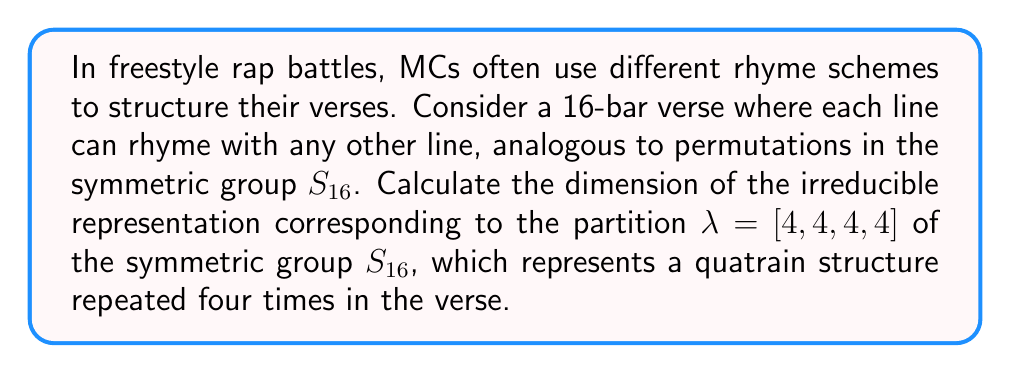Help me with this question. To calculate the dimension of the irreducible representation for the given partition, we'll use the hook length formula:

1) The hook length formula for the dimension of an irreducible representation of $S_n$ corresponding to a partition $\lambda$ is:

   $$\dim V_\lambda = \frac{n!}{\prod_{(i,j) \in \lambda} h(i,j)}$$

   where $h(i,j)$ is the hook length of the box $(i,j)$ in the Young diagram of $\lambda$.

2) For $\lambda = [4,4,4,4]$, the Young diagram is a $4 \times 4$ square.

3) Calculate the hook lengths for each box:
   $$\begin{array}{|c|c|c|c|}
   \hline
   7 & 6 & 5 & 4 \\
   \hline
   6 & 5 & 4 & 3 \\
   \hline
   5 & 4 & 3 & 2 \\
   \hline
   4 & 3 & 2 & 1 \\
   \hline
   \end{array}$$

4) Multiply all hook lengths:
   $$(7 \cdot 6 \cdot 5 \cdot 4) \cdot (6 \cdot 5 \cdot 4 \cdot 3) \cdot (5 \cdot 4 \cdot 3 \cdot 2) \cdot (4 \cdot 3 \cdot 2 \cdot 1)$$
   $$ = 7! \cdot 6! \cdot 5! \cdot 4!$$

5) Apply the formula:
   $$\dim V_{[4,4,4,4]} = \frac{16!}{7! \cdot 6! \cdot 5! \cdot 4!}$$

6) Simplify:
   $$\dim V_{[4,4,4,4]} = \frac{16 \cdot 15 \cdot 14 \cdot 13 \cdot 12 \cdot 11 \cdot 10 \cdot 9 \cdot 8}{7 \cdot 6 \cdot 5 \cdot 4 \cdot 3 \cdot 2} = 3,640,000$$
Answer: 3,640,000 